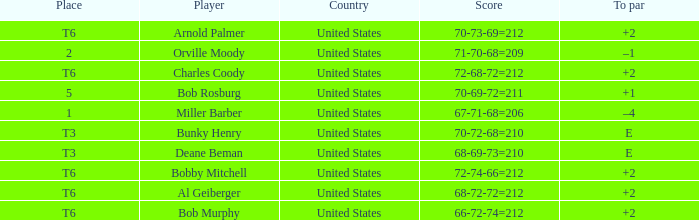What is the place of the 68-69-73=210? T3. 